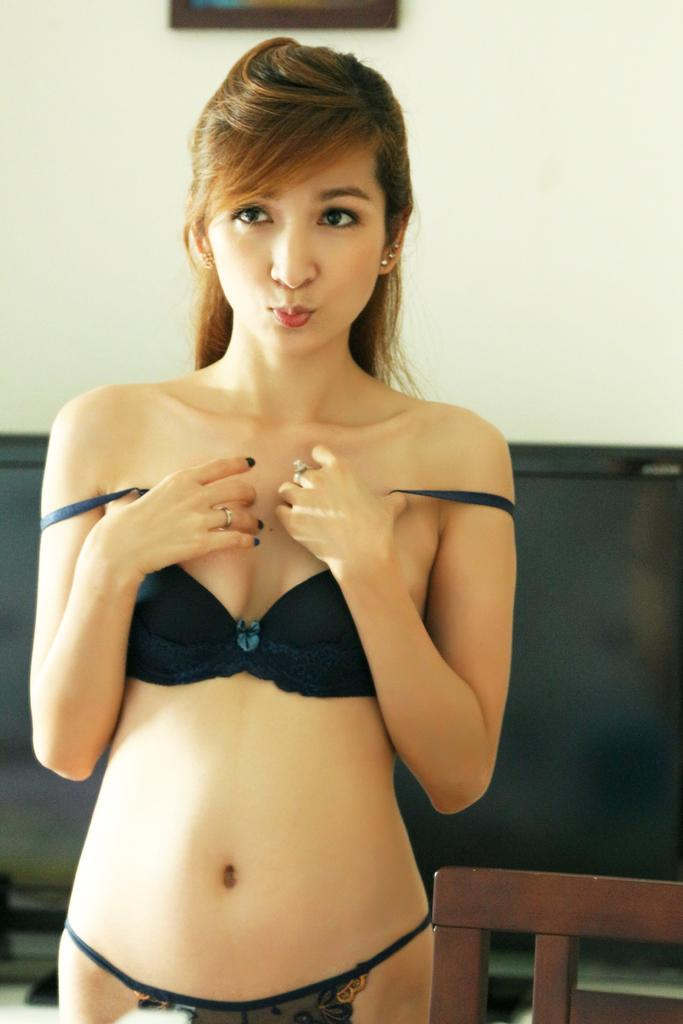What is the woman in the image wearing? The woman is wearing a bikini dress. Can you describe the setting of the image? There appears to be a chair in the image, and there is a wall in the background. What might the woman be doing in the image? It is not explicitly stated, but she could be sitting on the chair or standing near it. Is there any sleet visible in the image? No, there is no sleet present in the image. Is there a volleyball game happening in the image? No, there is no volleyball game or any indication of a party in the image. 